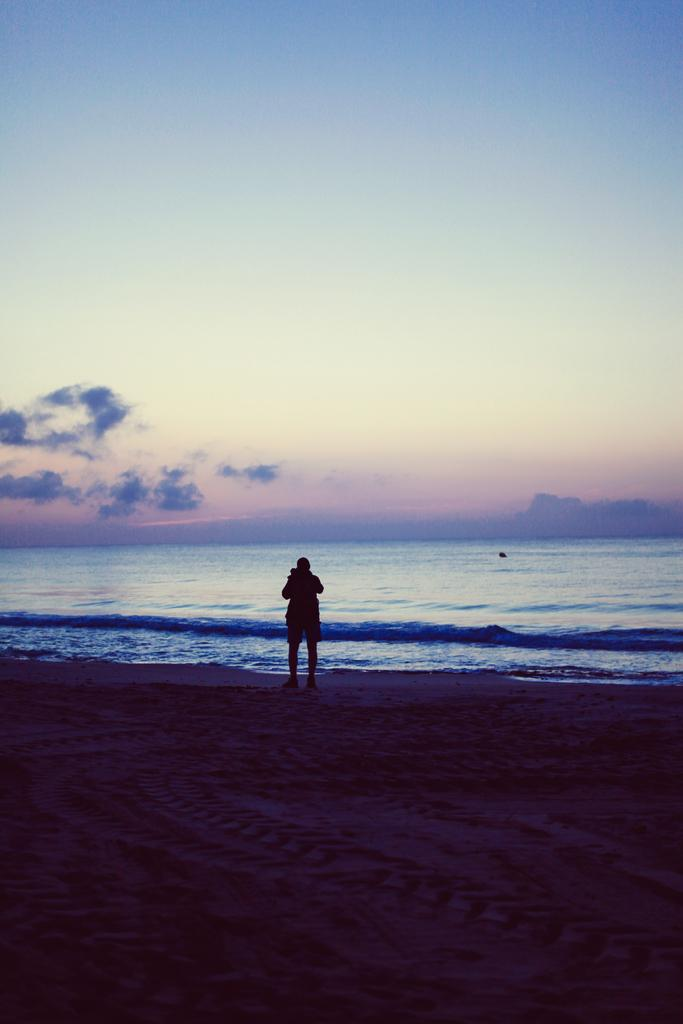What is the main subject of the image? There is a person standing in the image. Where is the person standing? The person is standing on the ground. What can be seen in the background of the image? There is water and the sky visible in the background of the image. How many trees can be seen in the image? There are no trees visible in the image. What is the level of noise in the image? The level of noise cannot be determined from the image, as it only shows a person standing on the ground with water and the sky in the background. 